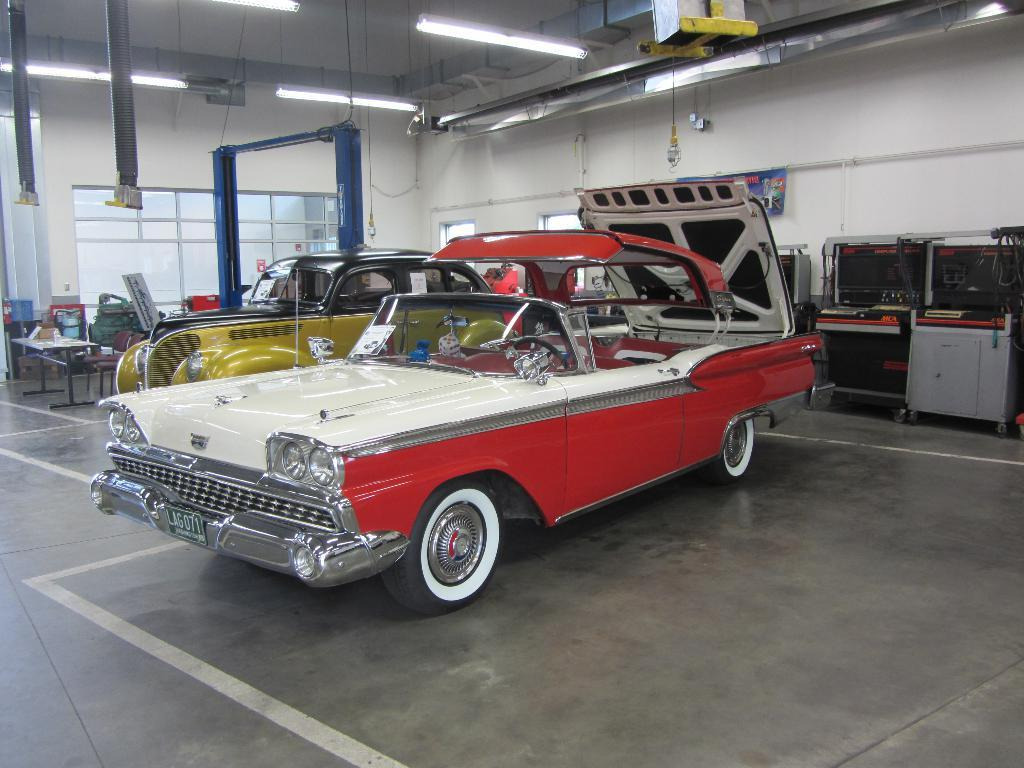What types of vehicles can be seen in the image? There are vehicles in the image, but the specific types cannot be determined from the provided facts. What piece of furniture is present in the image? There is a table in the image. What other furniture is present in the image? There are chairs in the image. Can you describe any other objects present in the image? There are other objects present in the image, but their specific nature cannot be determined from the provided facts. Where is the police officer standing in the image? There is no police officer present in the image. What type of kettle is visible on the table in the image? There is no kettle present in the image. 